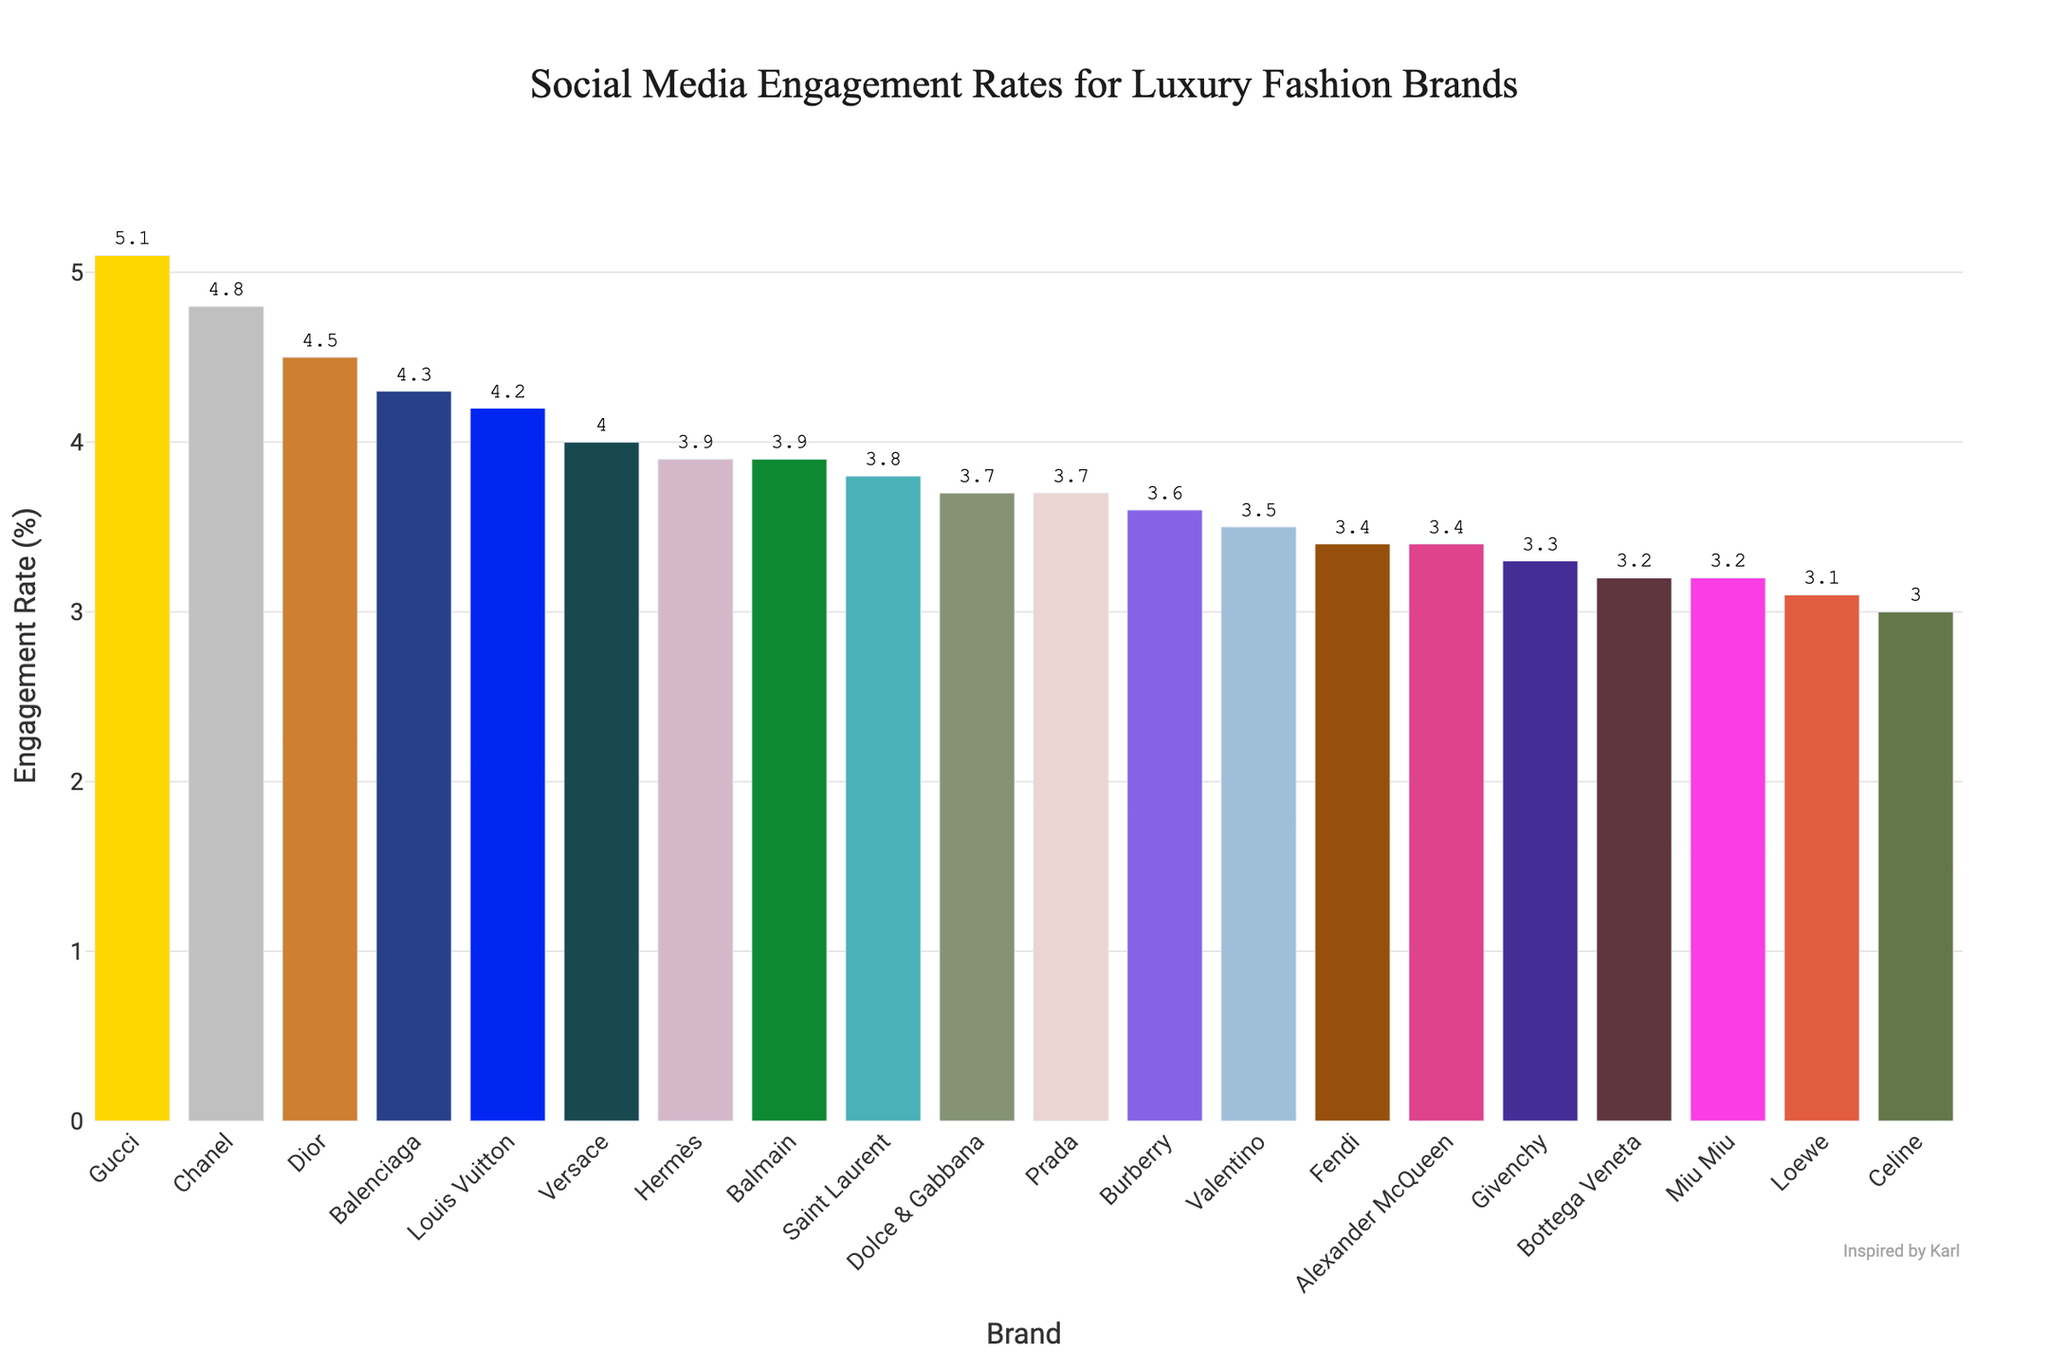What is the engagement rate of Gucci compared to Chanel? Gucci has an engagement rate of 5.1% and Chanel has an engagement rate of 4.8%. Comparing the two, Gucci has a higher engagement rate.
Answer: Gucci has a higher engagement rate Which brand has the lowest engagement rate? By looking at the figure, Celine has the lowest engagement rate at 3.0%.
Answer: Celine What is the average engagement rate of Dior, Balenciaga, and Hermès? Dior has an engagement rate of 4.5%, Balenciaga has 4.3%, and Hermès has 3.9%. The sum of their engagement rates is 4.5 + 4.3 + 3.9 = 12.7. The average is 12.7 / 3 = 4.23%.
Answer: 4.23% Which brand has a higher engagement rate: Prada or Versace? Prada has an engagement rate of 3.7% while Versace has an engagement rate of 4.0%. Versace has the higher engagement rate.
Answer: Versace Is the engagement rate of Bottega Veneta more than or less than the engagement rate of Valentino? Bottega Veneta has an engagement rate of 3.2% while Valentino has an engagement rate of 3.5%. Therefore, Bottega Veneta's engagement rate is less than Valentino's.
Answer: Less than What is the range of engagement rates across all brands? The highest engagement rate is 5.1% (Gucci) and the lowest is 3.0% (Celine). The range is calculated by subtracting the lowest from the highest: 5.1 - 3.0 = 2.1%.
Answer: 2.1% Which three brands have the highest engagement rates? By visual inspection, the three brands with the highest engagement rates are Gucci (5.1%), Chanel (4.8%), and Balenciaga (4.3%).
Answer: Gucci, Chanel, Balenciaga How does the engagement rate of Fendi compare to Saint Laurent? Fendi has an engagement rate of 3.4% while Saint Laurent has an engagement rate of 3.8%. Therefore, Saint Laurent has a higher engagement rate than Fendi.
Answer: Saint Laurent How many brands have an engagement rate above 4%? Counting from the visual data, the brands with an engagement rate above 4% are Gucci, Chanel, Balenciaga, Versace, Louis Vuitton, Dior. In total, there are 6 brands.
Answer: 6 What is the sum of the engagement rates for Givenchy and Miu Miu? Givenchy has an engagement rate of 3.3% and Miu Miu has 3.2%. Summing them up: 3.3 + 3.2 = 6.5%.
Answer: 6.5% 